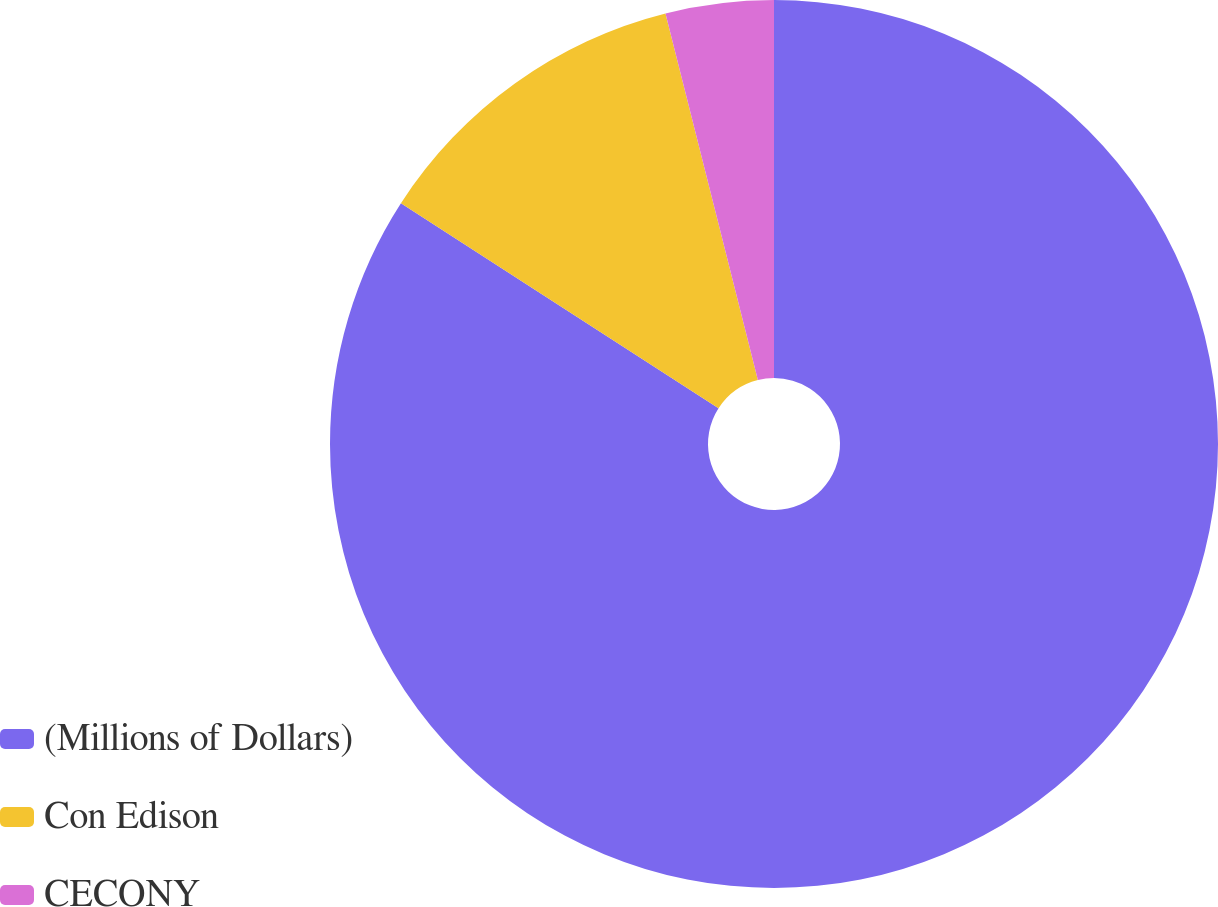Convert chart. <chart><loc_0><loc_0><loc_500><loc_500><pie_chart><fcel>(Millions of Dollars)<fcel>Con Edison<fcel>CECONY<nl><fcel>84.13%<fcel>11.95%<fcel>3.93%<nl></chart> 